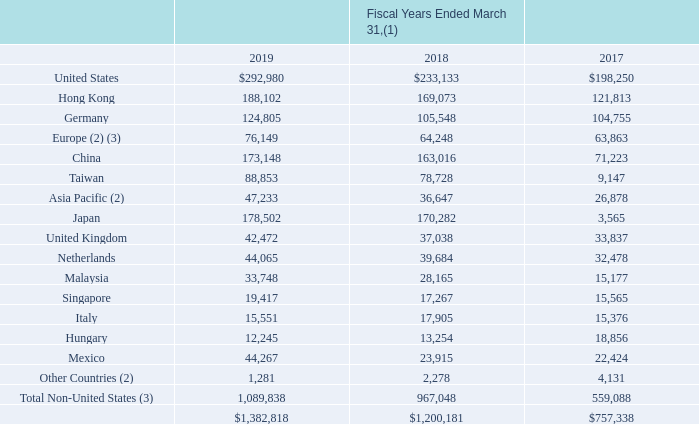The following highlights net sales by geographic location (amounts in thousands):
(1) Revenues are attributed to countries or regions based on the location of the customer. Net Sales to one customer, TTI, Inc., exceeded 10% of total net sales as follows: $184.3 million, $133.5 million and $104.4 million in fiscal years 2019, 2018 and 2017, respectively.
(2) No country included in this caption exceeded 3% of consolidated net sales for fiscal years 2019, 2018 and 2017.
(3) Fiscal years ended March 31, 2018 and 2017 adjusted due to the adoption of ASC 606.
Which years does the table provide information for net sales by geographic location? 2019, 2018, 2017. What was the net sales in Hong Kong in 2018?
Answer scale should be: thousand. 169,073. What was the net sales in Singapore in 2017?
Answer scale should be: thousand. 15,565. What was the change in net sales in Mexico between 2017 and 2018?
Answer scale should be: thousand. 23,915-22,424
Answer: 1491. Which years did the total net sales in all regions exceed $1,000,000 thousand? (2019:1,382,818),(2018:1,200,181)
Answer: 2019, 2018. What was the percentage change in the net sales from Other Countries between 2018 and 2019?
Answer scale should be: percent. (1,281-2,278)/2,278
Answer: -43.77. 